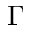<formula> <loc_0><loc_0><loc_500><loc_500>\Gamma</formula> 